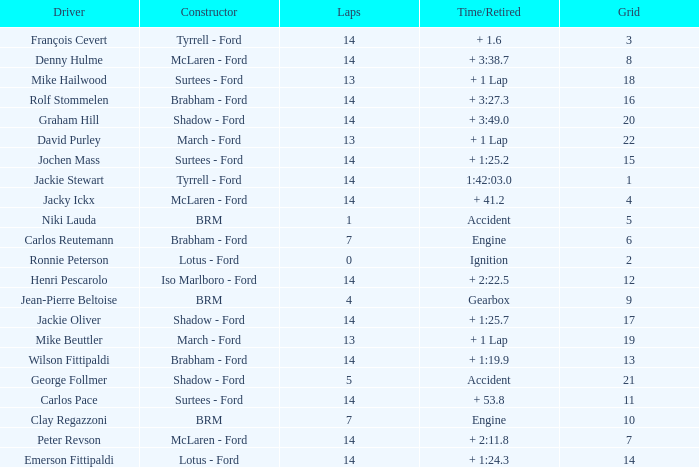What is the low lap total for henri pescarolo with a grad larger than 6? 14.0. 